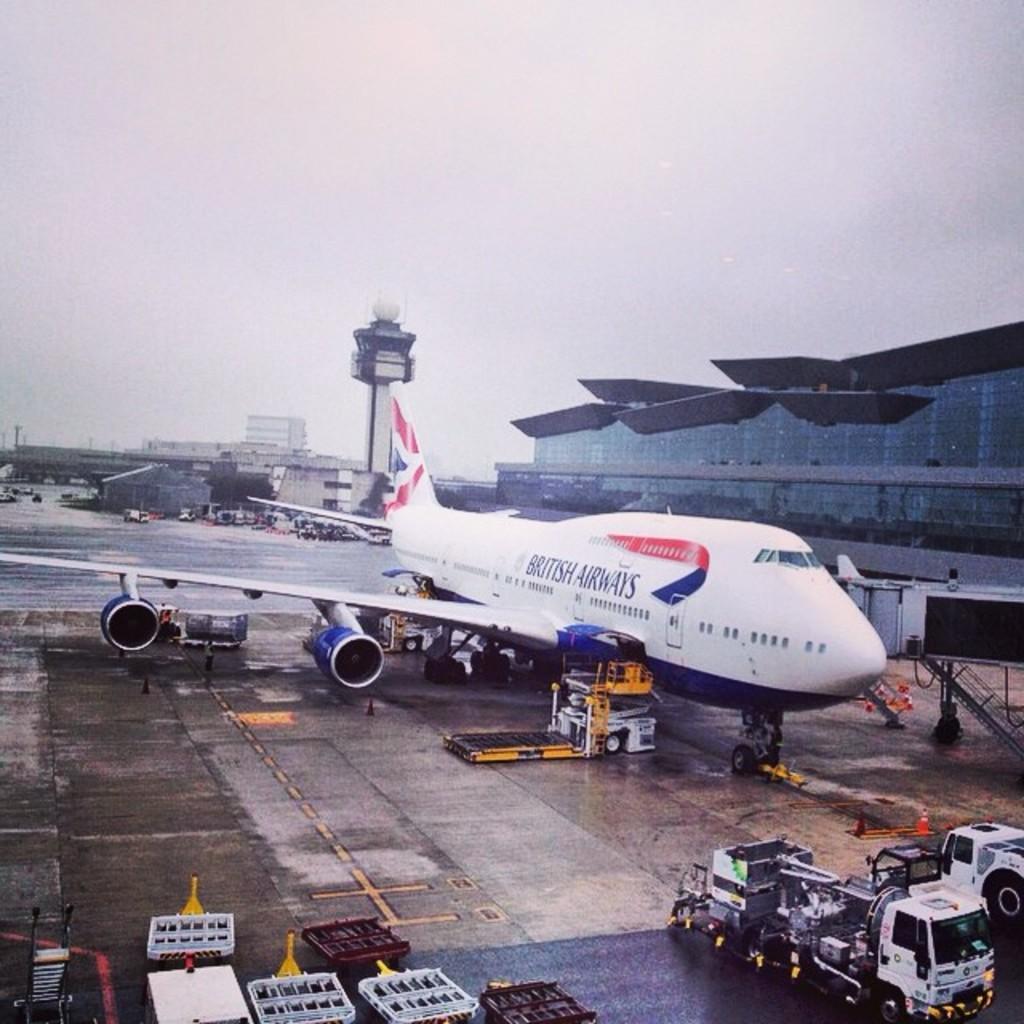Can you describe this image briefly? Here there is an airplane, these are vehicles, this is building and a sky. 